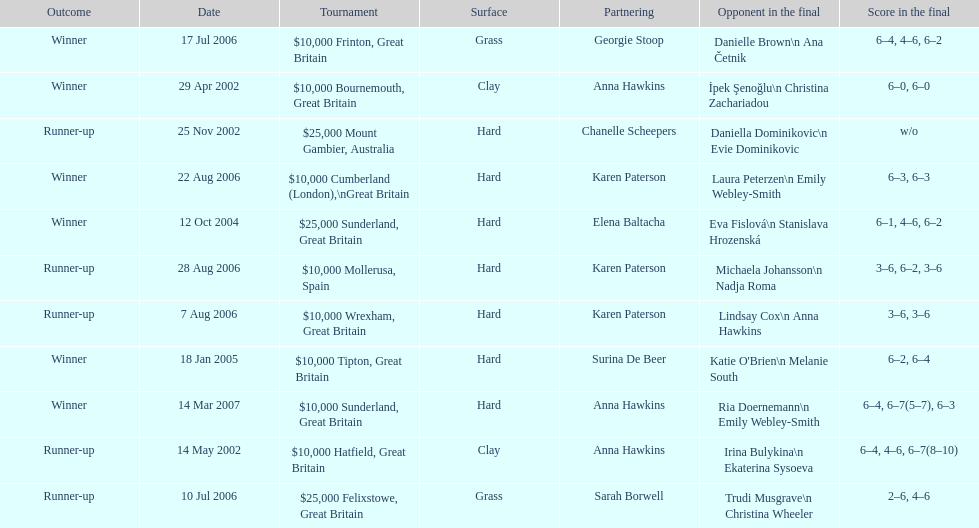What is the partnering name above chanelle scheepers? Anna Hawkins. 